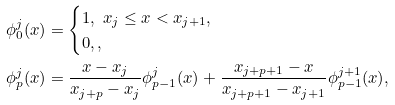Convert formula to latex. <formula><loc_0><loc_0><loc_500><loc_500>\phi ^ { j } _ { 0 } ( x ) & = \begin{cases} 1 , \ x _ { j } \leq x < x _ { j + 1 } , \\ 0 , , \\ \end{cases} \\ \phi ^ { j } _ { p } ( x ) & = \frac { x - x _ { j } } { x _ { j + p } - x _ { j } } \phi ^ { j } _ { p - 1 } ( x ) + \frac { x _ { j + p + 1 } - x } { x _ { j + p + 1 } - x _ { j + 1 } } \phi ^ { j + 1 } _ { p - 1 } ( x ) ,</formula> 